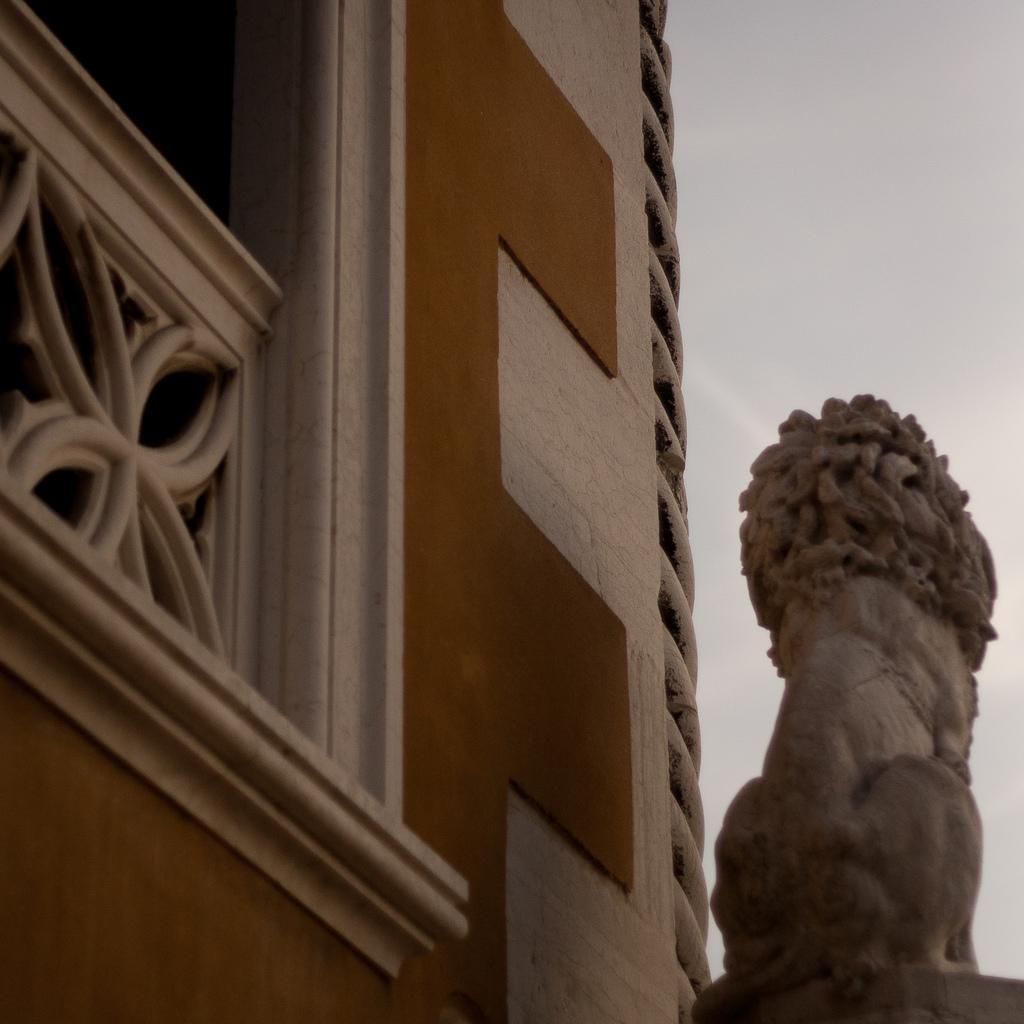Please provide a concise description of this image. In this picture I can see a building, there is a sculpture, and in the background there is the sky. 